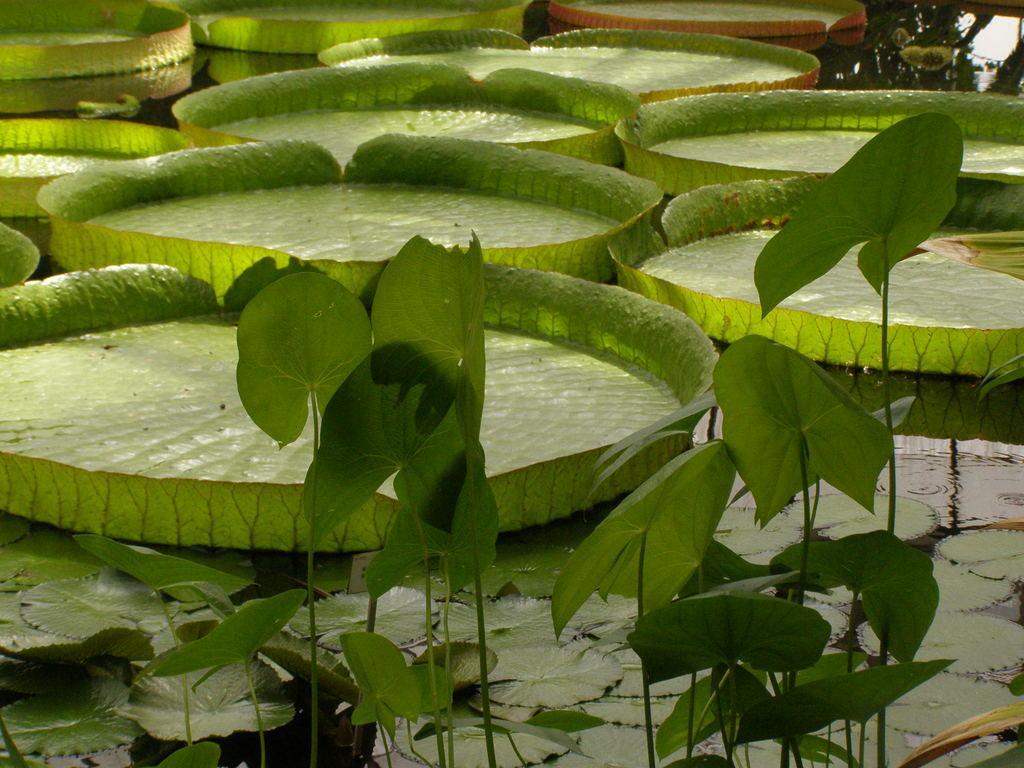How would you summarize this image in a sentence or two? In this image we can see the plants and also the leaves. 